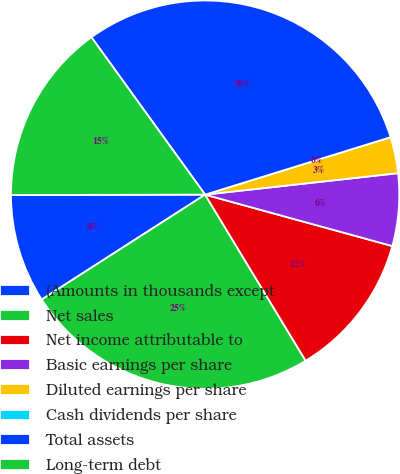Convert chart to OTSL. <chart><loc_0><loc_0><loc_500><loc_500><pie_chart><fcel>(Amounts in thousands except<fcel>Net sales<fcel>Net income attributable to<fcel>Basic earnings per share<fcel>Diluted earnings per share<fcel>Cash dividends per share<fcel>Total assets<fcel>Long-term debt<nl><fcel>9.05%<fcel>24.58%<fcel>12.07%<fcel>6.03%<fcel>3.02%<fcel>0.0%<fcel>30.17%<fcel>15.08%<nl></chart> 